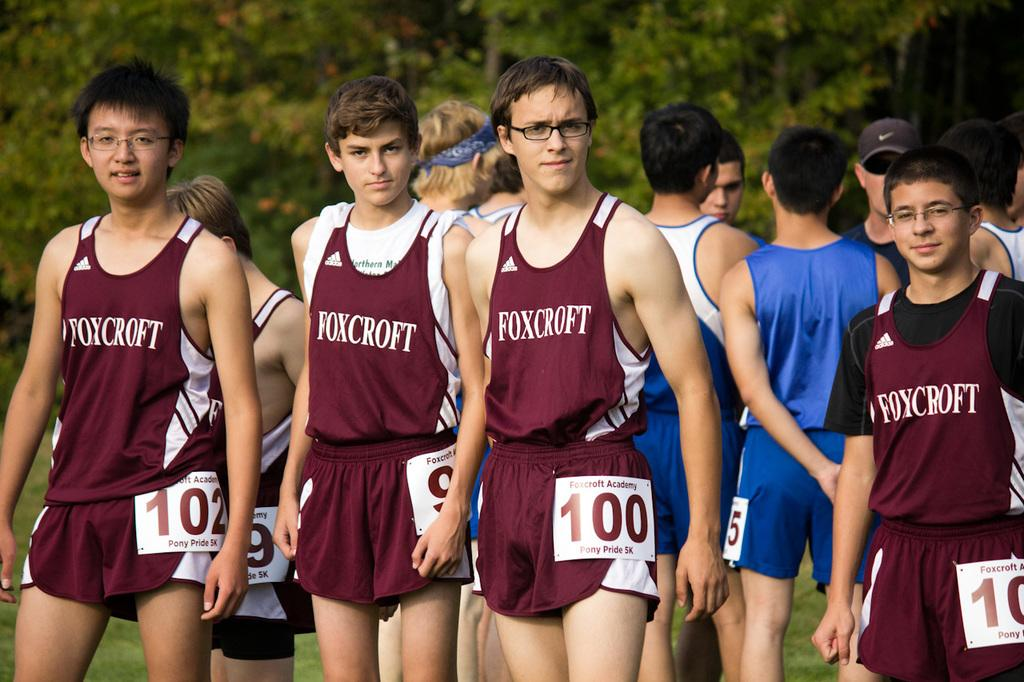<image>
Present a compact description of the photo's key features. a few runners wearing the name Foxcroft on their jerseys 